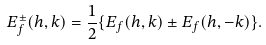<formula> <loc_0><loc_0><loc_500><loc_500>E _ { f } ^ { \pm } ( h , k ) = \frac { 1 } { 2 } \{ E _ { f } ( h , k ) \pm E _ { f } ( h , - k ) \} .</formula> 